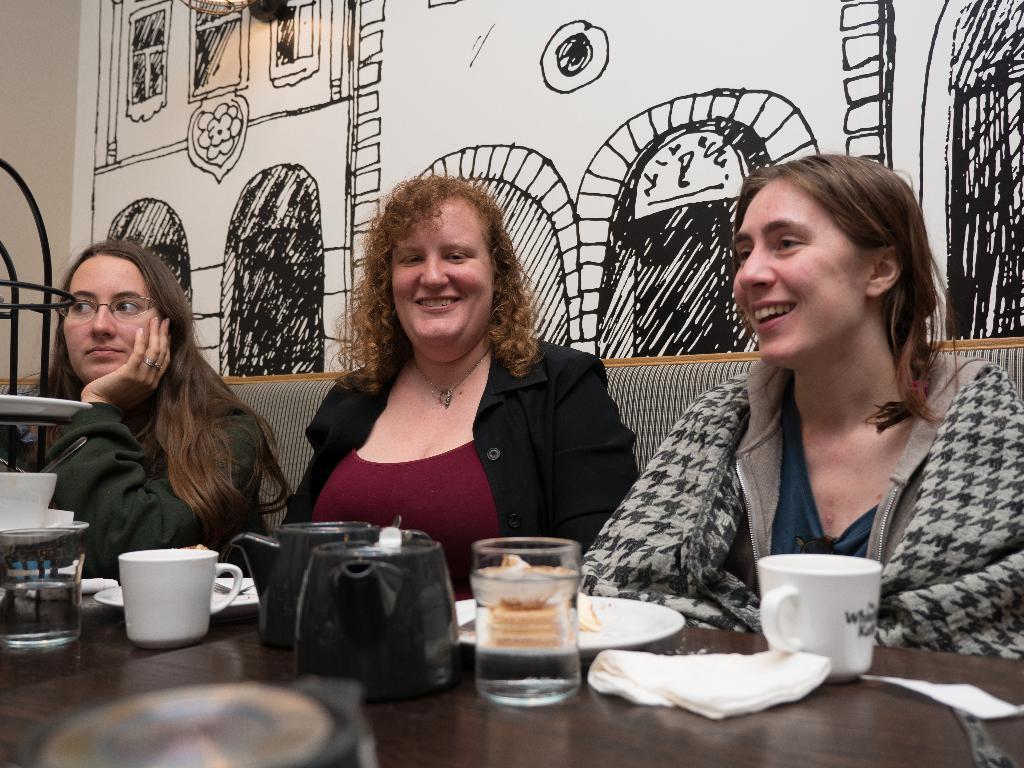How would you summarize this image in a sentence or two? In this picture i can see inside view of building. And i can see a wall back side of the image and there is a drawing attached to the wall. and i can see a sofa set. and i can see a three women sitting on the sofa set. On the right side there is a woman wearing a black skirt she is smiling. And middle a woman sit on the sofa set wearing black color jacket. And left side a woman wearing a spectacles along with black color jacket she is wearing a ring on her finger. in the table i can see a coffee mug ,glass contain a water and i can see a plate contain a food ,i can a tissue paper. on the left side there is a glass contain a water. there is a plate kept on the table. 